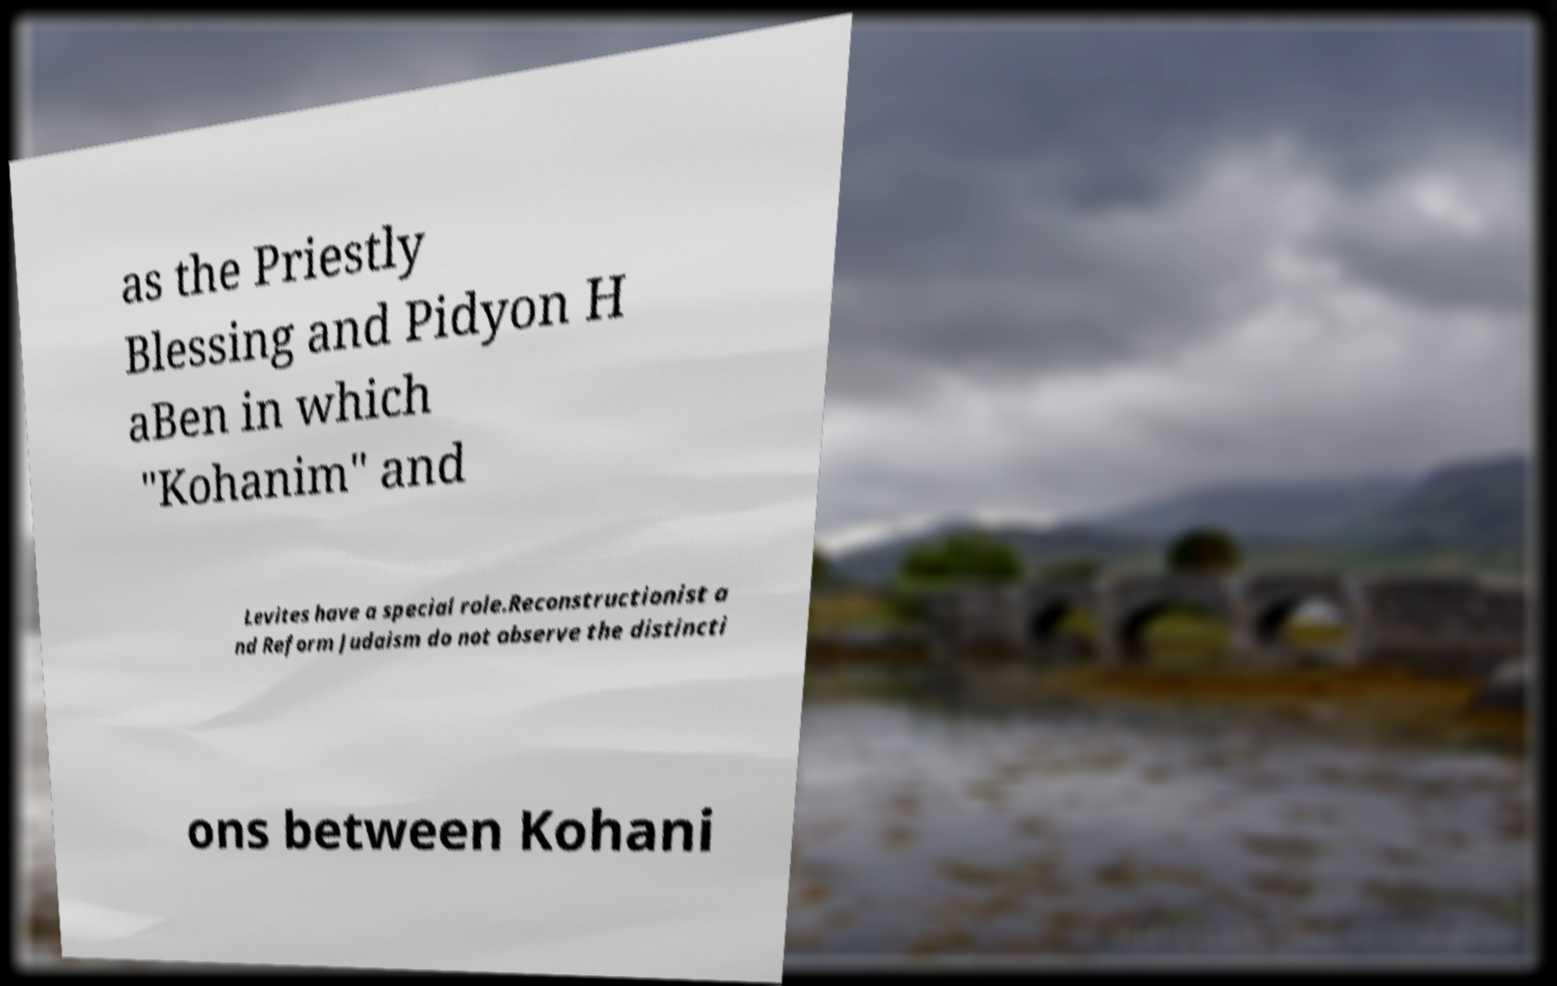For documentation purposes, I need the text within this image transcribed. Could you provide that? as the Priestly Blessing and Pidyon H aBen in which "Kohanim" and Levites have a special role.Reconstructionist a nd Reform Judaism do not observe the distincti ons between Kohani 